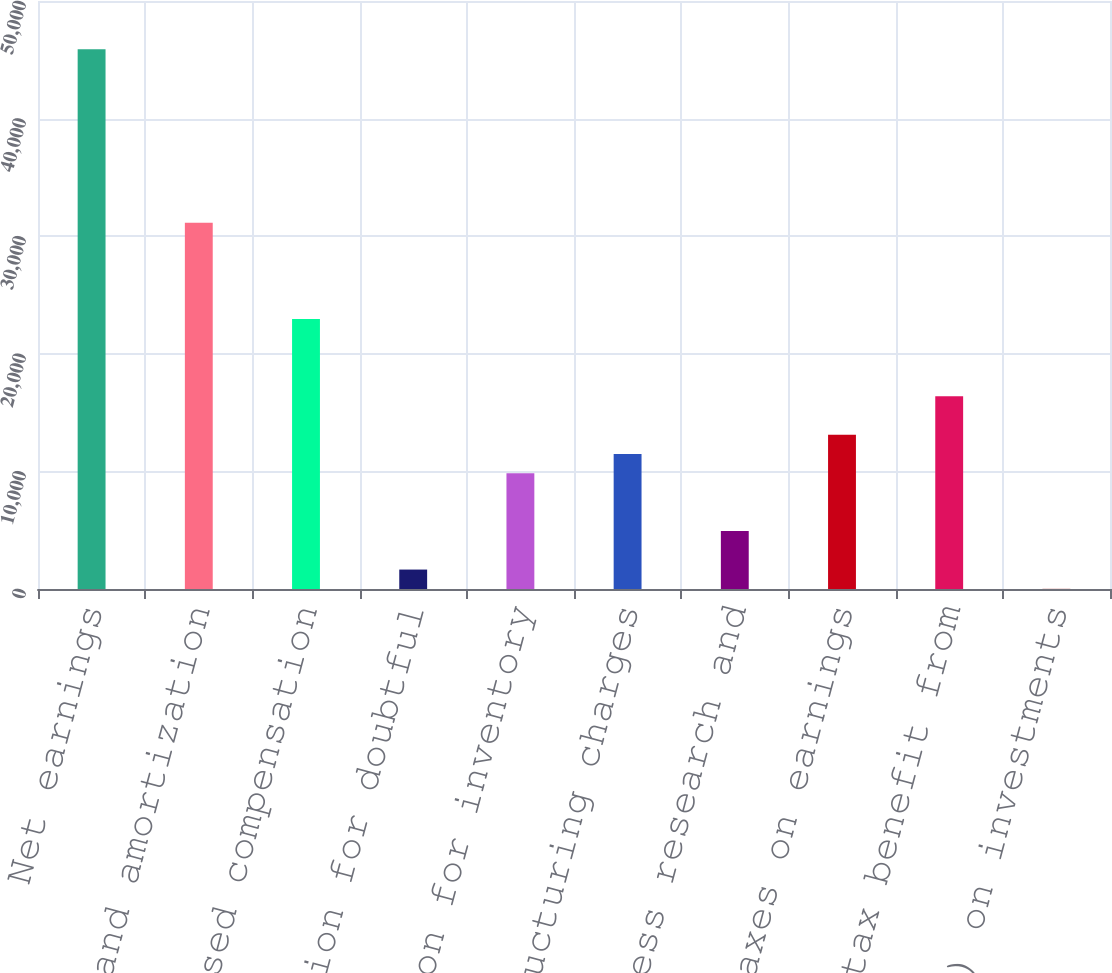<chart> <loc_0><loc_0><loc_500><loc_500><bar_chart><fcel>Net earnings<fcel>Depreciation and amortization<fcel>Stock-based compensation<fcel>Provision for doubtful<fcel>Provision for inventory<fcel>Restructuring charges<fcel>In-process research and<fcel>Deferred taxes on earnings<fcel>Excess tax benefit from<fcel>Losses (gains) on investments<nl><fcel>45894.8<fcel>31147.4<fcel>22954.4<fcel>1652.6<fcel>9845.6<fcel>11484.2<fcel>4929.8<fcel>13122.8<fcel>16400<fcel>14<nl></chart> 